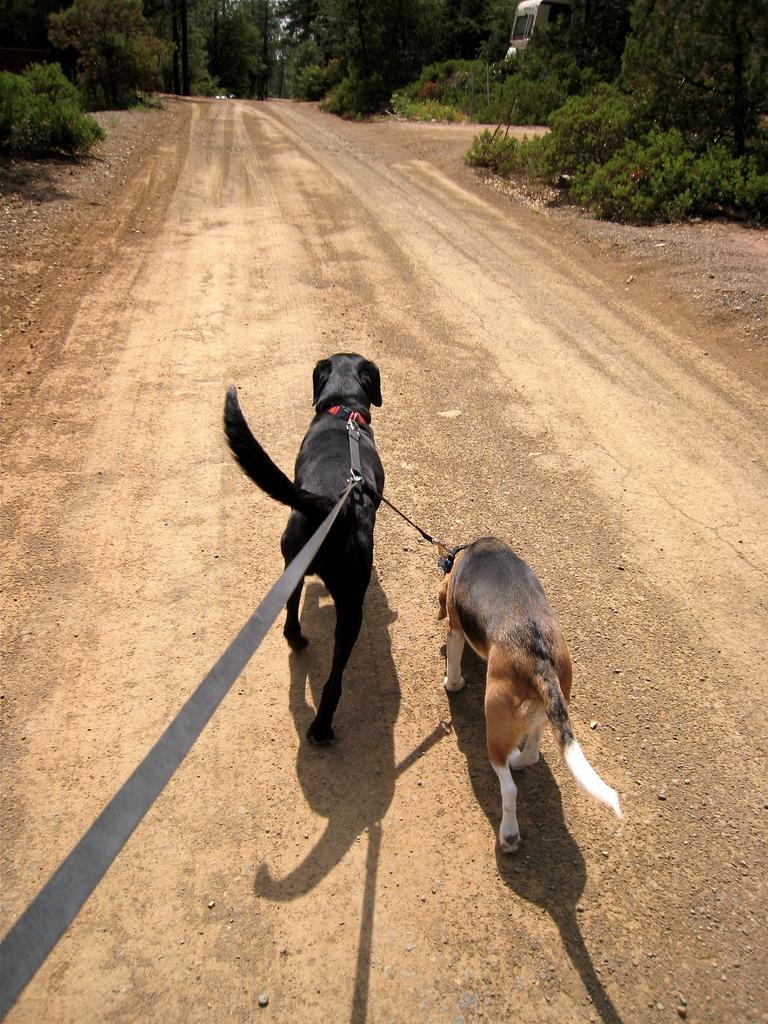Please provide a concise description of this image. In this image there are trees in the left corner. There are trees and an object in the right corner. There are dogs in the foreground. There are trees in the background. And there is mud road at the bottom. 